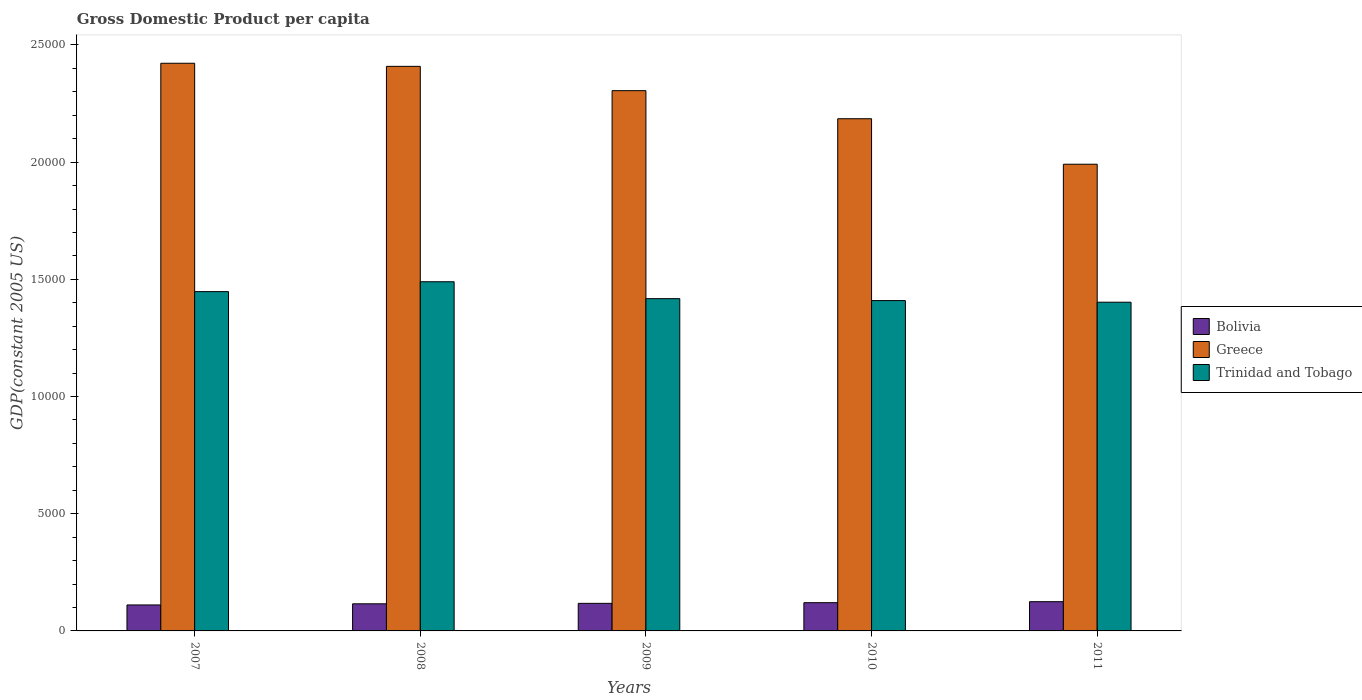How many groups of bars are there?
Give a very brief answer. 5. How many bars are there on the 3rd tick from the left?
Your response must be concise. 3. How many bars are there on the 2nd tick from the right?
Offer a terse response. 3. What is the label of the 4th group of bars from the left?
Your answer should be compact. 2010. What is the GDP per capita in Greece in 2007?
Your response must be concise. 2.42e+04. Across all years, what is the maximum GDP per capita in Trinidad and Tobago?
Make the answer very short. 1.49e+04. Across all years, what is the minimum GDP per capita in Greece?
Provide a succinct answer. 1.99e+04. In which year was the GDP per capita in Trinidad and Tobago maximum?
Offer a very short reply. 2008. In which year was the GDP per capita in Trinidad and Tobago minimum?
Offer a very short reply. 2011. What is the total GDP per capita in Bolivia in the graph?
Your answer should be very brief. 5894.78. What is the difference between the GDP per capita in Bolivia in 2007 and that in 2008?
Your answer should be very brief. -48.73. What is the difference between the GDP per capita in Bolivia in 2007 and the GDP per capita in Greece in 2009?
Ensure brevity in your answer.  -2.19e+04. What is the average GDP per capita in Bolivia per year?
Keep it short and to the point. 1178.96. In the year 2010, what is the difference between the GDP per capita in Greece and GDP per capita in Bolivia?
Your answer should be very brief. 2.06e+04. In how many years, is the GDP per capita in Greece greater than 20000 US$?
Your answer should be compact. 4. What is the ratio of the GDP per capita in Trinidad and Tobago in 2007 to that in 2011?
Offer a terse response. 1.03. Is the GDP per capita in Greece in 2008 less than that in 2011?
Your response must be concise. No. What is the difference between the highest and the second highest GDP per capita in Trinidad and Tobago?
Your response must be concise. 421.24. What is the difference between the highest and the lowest GDP per capita in Bolivia?
Your answer should be compact. 139.55. In how many years, is the GDP per capita in Bolivia greater than the average GDP per capita in Bolivia taken over all years?
Offer a terse response. 2. Is the sum of the GDP per capita in Trinidad and Tobago in 2008 and 2009 greater than the maximum GDP per capita in Greece across all years?
Keep it short and to the point. Yes. What does the 2nd bar from the left in 2011 represents?
Provide a short and direct response. Greece. What does the 1st bar from the right in 2009 represents?
Provide a short and direct response. Trinidad and Tobago. How many bars are there?
Provide a succinct answer. 15. Are all the bars in the graph horizontal?
Your answer should be compact. No. Are the values on the major ticks of Y-axis written in scientific E-notation?
Your answer should be very brief. No. Does the graph contain any zero values?
Your response must be concise. No. Does the graph contain grids?
Offer a very short reply. No. How many legend labels are there?
Offer a very short reply. 3. How are the legend labels stacked?
Your answer should be very brief. Vertical. What is the title of the graph?
Provide a succinct answer. Gross Domestic Product per capita. What is the label or title of the Y-axis?
Your response must be concise. GDP(constant 2005 US). What is the GDP(constant 2005 US) in Bolivia in 2007?
Make the answer very short. 1108.29. What is the GDP(constant 2005 US) in Greece in 2007?
Give a very brief answer. 2.42e+04. What is the GDP(constant 2005 US) in Trinidad and Tobago in 2007?
Ensure brevity in your answer.  1.45e+04. What is the GDP(constant 2005 US) in Bolivia in 2008?
Give a very brief answer. 1157.02. What is the GDP(constant 2005 US) in Greece in 2008?
Your answer should be compact. 2.41e+04. What is the GDP(constant 2005 US) in Trinidad and Tobago in 2008?
Your answer should be very brief. 1.49e+04. What is the GDP(constant 2005 US) of Bolivia in 2009?
Keep it short and to the point. 1176.39. What is the GDP(constant 2005 US) of Greece in 2009?
Your response must be concise. 2.31e+04. What is the GDP(constant 2005 US) of Trinidad and Tobago in 2009?
Offer a very short reply. 1.42e+04. What is the GDP(constant 2005 US) of Bolivia in 2010?
Your response must be concise. 1205.24. What is the GDP(constant 2005 US) of Greece in 2010?
Offer a very short reply. 2.19e+04. What is the GDP(constant 2005 US) in Trinidad and Tobago in 2010?
Offer a very short reply. 1.41e+04. What is the GDP(constant 2005 US) in Bolivia in 2011?
Your response must be concise. 1247.84. What is the GDP(constant 2005 US) in Greece in 2011?
Give a very brief answer. 1.99e+04. What is the GDP(constant 2005 US) in Trinidad and Tobago in 2011?
Make the answer very short. 1.40e+04. Across all years, what is the maximum GDP(constant 2005 US) in Bolivia?
Your response must be concise. 1247.84. Across all years, what is the maximum GDP(constant 2005 US) in Greece?
Your response must be concise. 2.42e+04. Across all years, what is the maximum GDP(constant 2005 US) in Trinidad and Tobago?
Provide a short and direct response. 1.49e+04. Across all years, what is the minimum GDP(constant 2005 US) of Bolivia?
Make the answer very short. 1108.29. Across all years, what is the minimum GDP(constant 2005 US) in Greece?
Give a very brief answer. 1.99e+04. Across all years, what is the minimum GDP(constant 2005 US) in Trinidad and Tobago?
Your answer should be compact. 1.40e+04. What is the total GDP(constant 2005 US) of Bolivia in the graph?
Provide a short and direct response. 5894.78. What is the total GDP(constant 2005 US) of Greece in the graph?
Ensure brevity in your answer.  1.13e+05. What is the total GDP(constant 2005 US) in Trinidad and Tobago in the graph?
Your answer should be very brief. 7.17e+04. What is the difference between the GDP(constant 2005 US) in Bolivia in 2007 and that in 2008?
Ensure brevity in your answer.  -48.73. What is the difference between the GDP(constant 2005 US) of Greece in 2007 and that in 2008?
Your answer should be compact. 131.75. What is the difference between the GDP(constant 2005 US) of Trinidad and Tobago in 2007 and that in 2008?
Offer a terse response. -421.24. What is the difference between the GDP(constant 2005 US) in Bolivia in 2007 and that in 2009?
Your answer should be very brief. -68.1. What is the difference between the GDP(constant 2005 US) of Greece in 2007 and that in 2009?
Your answer should be very brief. 1169.02. What is the difference between the GDP(constant 2005 US) of Trinidad and Tobago in 2007 and that in 2009?
Your answer should be compact. 300.1. What is the difference between the GDP(constant 2005 US) in Bolivia in 2007 and that in 2010?
Offer a very short reply. -96.95. What is the difference between the GDP(constant 2005 US) in Greece in 2007 and that in 2010?
Your response must be concise. 2366.25. What is the difference between the GDP(constant 2005 US) of Trinidad and Tobago in 2007 and that in 2010?
Your answer should be very brief. 382.35. What is the difference between the GDP(constant 2005 US) in Bolivia in 2007 and that in 2011?
Keep it short and to the point. -139.55. What is the difference between the GDP(constant 2005 US) in Greece in 2007 and that in 2011?
Offer a terse response. 4307.98. What is the difference between the GDP(constant 2005 US) in Trinidad and Tobago in 2007 and that in 2011?
Ensure brevity in your answer.  452.1. What is the difference between the GDP(constant 2005 US) of Bolivia in 2008 and that in 2009?
Your response must be concise. -19.37. What is the difference between the GDP(constant 2005 US) of Greece in 2008 and that in 2009?
Offer a terse response. 1037.27. What is the difference between the GDP(constant 2005 US) of Trinidad and Tobago in 2008 and that in 2009?
Offer a very short reply. 721.35. What is the difference between the GDP(constant 2005 US) in Bolivia in 2008 and that in 2010?
Ensure brevity in your answer.  -48.23. What is the difference between the GDP(constant 2005 US) in Greece in 2008 and that in 2010?
Offer a very short reply. 2234.5. What is the difference between the GDP(constant 2005 US) of Trinidad and Tobago in 2008 and that in 2010?
Give a very brief answer. 803.6. What is the difference between the GDP(constant 2005 US) of Bolivia in 2008 and that in 2011?
Your answer should be very brief. -90.82. What is the difference between the GDP(constant 2005 US) of Greece in 2008 and that in 2011?
Your answer should be compact. 4176.24. What is the difference between the GDP(constant 2005 US) in Trinidad and Tobago in 2008 and that in 2011?
Keep it short and to the point. 873.34. What is the difference between the GDP(constant 2005 US) of Bolivia in 2009 and that in 2010?
Your answer should be very brief. -28.85. What is the difference between the GDP(constant 2005 US) of Greece in 2009 and that in 2010?
Provide a succinct answer. 1197.23. What is the difference between the GDP(constant 2005 US) of Trinidad and Tobago in 2009 and that in 2010?
Provide a succinct answer. 82.25. What is the difference between the GDP(constant 2005 US) in Bolivia in 2009 and that in 2011?
Offer a terse response. -71.45. What is the difference between the GDP(constant 2005 US) of Greece in 2009 and that in 2011?
Keep it short and to the point. 3138.97. What is the difference between the GDP(constant 2005 US) of Trinidad and Tobago in 2009 and that in 2011?
Provide a succinct answer. 152. What is the difference between the GDP(constant 2005 US) of Bolivia in 2010 and that in 2011?
Ensure brevity in your answer.  -42.59. What is the difference between the GDP(constant 2005 US) in Greece in 2010 and that in 2011?
Give a very brief answer. 1941.73. What is the difference between the GDP(constant 2005 US) in Trinidad and Tobago in 2010 and that in 2011?
Provide a succinct answer. 69.74. What is the difference between the GDP(constant 2005 US) in Bolivia in 2007 and the GDP(constant 2005 US) in Greece in 2008?
Offer a very short reply. -2.30e+04. What is the difference between the GDP(constant 2005 US) in Bolivia in 2007 and the GDP(constant 2005 US) in Trinidad and Tobago in 2008?
Offer a very short reply. -1.38e+04. What is the difference between the GDP(constant 2005 US) in Greece in 2007 and the GDP(constant 2005 US) in Trinidad and Tobago in 2008?
Provide a succinct answer. 9321.65. What is the difference between the GDP(constant 2005 US) of Bolivia in 2007 and the GDP(constant 2005 US) of Greece in 2009?
Your answer should be very brief. -2.19e+04. What is the difference between the GDP(constant 2005 US) of Bolivia in 2007 and the GDP(constant 2005 US) of Trinidad and Tobago in 2009?
Make the answer very short. -1.31e+04. What is the difference between the GDP(constant 2005 US) of Greece in 2007 and the GDP(constant 2005 US) of Trinidad and Tobago in 2009?
Your response must be concise. 1.00e+04. What is the difference between the GDP(constant 2005 US) in Bolivia in 2007 and the GDP(constant 2005 US) in Greece in 2010?
Your answer should be compact. -2.07e+04. What is the difference between the GDP(constant 2005 US) in Bolivia in 2007 and the GDP(constant 2005 US) in Trinidad and Tobago in 2010?
Give a very brief answer. -1.30e+04. What is the difference between the GDP(constant 2005 US) in Greece in 2007 and the GDP(constant 2005 US) in Trinidad and Tobago in 2010?
Your answer should be very brief. 1.01e+04. What is the difference between the GDP(constant 2005 US) of Bolivia in 2007 and the GDP(constant 2005 US) of Greece in 2011?
Your answer should be very brief. -1.88e+04. What is the difference between the GDP(constant 2005 US) in Bolivia in 2007 and the GDP(constant 2005 US) in Trinidad and Tobago in 2011?
Offer a terse response. -1.29e+04. What is the difference between the GDP(constant 2005 US) of Greece in 2007 and the GDP(constant 2005 US) of Trinidad and Tobago in 2011?
Your answer should be compact. 1.02e+04. What is the difference between the GDP(constant 2005 US) of Bolivia in 2008 and the GDP(constant 2005 US) of Greece in 2009?
Offer a terse response. -2.19e+04. What is the difference between the GDP(constant 2005 US) in Bolivia in 2008 and the GDP(constant 2005 US) in Trinidad and Tobago in 2009?
Give a very brief answer. -1.30e+04. What is the difference between the GDP(constant 2005 US) of Greece in 2008 and the GDP(constant 2005 US) of Trinidad and Tobago in 2009?
Offer a terse response. 9911.25. What is the difference between the GDP(constant 2005 US) of Bolivia in 2008 and the GDP(constant 2005 US) of Greece in 2010?
Keep it short and to the point. -2.07e+04. What is the difference between the GDP(constant 2005 US) in Bolivia in 2008 and the GDP(constant 2005 US) in Trinidad and Tobago in 2010?
Offer a very short reply. -1.29e+04. What is the difference between the GDP(constant 2005 US) of Greece in 2008 and the GDP(constant 2005 US) of Trinidad and Tobago in 2010?
Provide a short and direct response. 9993.5. What is the difference between the GDP(constant 2005 US) in Bolivia in 2008 and the GDP(constant 2005 US) in Greece in 2011?
Your answer should be compact. -1.88e+04. What is the difference between the GDP(constant 2005 US) of Bolivia in 2008 and the GDP(constant 2005 US) of Trinidad and Tobago in 2011?
Your answer should be compact. -1.29e+04. What is the difference between the GDP(constant 2005 US) in Greece in 2008 and the GDP(constant 2005 US) in Trinidad and Tobago in 2011?
Your response must be concise. 1.01e+04. What is the difference between the GDP(constant 2005 US) of Bolivia in 2009 and the GDP(constant 2005 US) of Greece in 2010?
Your response must be concise. -2.07e+04. What is the difference between the GDP(constant 2005 US) in Bolivia in 2009 and the GDP(constant 2005 US) in Trinidad and Tobago in 2010?
Offer a very short reply. -1.29e+04. What is the difference between the GDP(constant 2005 US) of Greece in 2009 and the GDP(constant 2005 US) of Trinidad and Tobago in 2010?
Give a very brief answer. 8956.23. What is the difference between the GDP(constant 2005 US) in Bolivia in 2009 and the GDP(constant 2005 US) in Greece in 2011?
Ensure brevity in your answer.  -1.87e+04. What is the difference between the GDP(constant 2005 US) of Bolivia in 2009 and the GDP(constant 2005 US) of Trinidad and Tobago in 2011?
Your answer should be very brief. -1.28e+04. What is the difference between the GDP(constant 2005 US) of Greece in 2009 and the GDP(constant 2005 US) of Trinidad and Tobago in 2011?
Keep it short and to the point. 9025.97. What is the difference between the GDP(constant 2005 US) of Bolivia in 2010 and the GDP(constant 2005 US) of Greece in 2011?
Provide a short and direct response. -1.87e+04. What is the difference between the GDP(constant 2005 US) in Bolivia in 2010 and the GDP(constant 2005 US) in Trinidad and Tobago in 2011?
Keep it short and to the point. -1.28e+04. What is the difference between the GDP(constant 2005 US) in Greece in 2010 and the GDP(constant 2005 US) in Trinidad and Tobago in 2011?
Provide a succinct answer. 7828.74. What is the average GDP(constant 2005 US) in Bolivia per year?
Ensure brevity in your answer.  1178.96. What is the average GDP(constant 2005 US) of Greece per year?
Provide a short and direct response. 2.26e+04. What is the average GDP(constant 2005 US) of Trinidad and Tobago per year?
Your response must be concise. 1.43e+04. In the year 2007, what is the difference between the GDP(constant 2005 US) in Bolivia and GDP(constant 2005 US) in Greece?
Provide a succinct answer. -2.31e+04. In the year 2007, what is the difference between the GDP(constant 2005 US) of Bolivia and GDP(constant 2005 US) of Trinidad and Tobago?
Keep it short and to the point. -1.34e+04. In the year 2007, what is the difference between the GDP(constant 2005 US) of Greece and GDP(constant 2005 US) of Trinidad and Tobago?
Your answer should be compact. 9742.89. In the year 2008, what is the difference between the GDP(constant 2005 US) in Bolivia and GDP(constant 2005 US) in Greece?
Provide a succinct answer. -2.29e+04. In the year 2008, what is the difference between the GDP(constant 2005 US) of Bolivia and GDP(constant 2005 US) of Trinidad and Tobago?
Your response must be concise. -1.37e+04. In the year 2008, what is the difference between the GDP(constant 2005 US) of Greece and GDP(constant 2005 US) of Trinidad and Tobago?
Ensure brevity in your answer.  9189.9. In the year 2009, what is the difference between the GDP(constant 2005 US) of Bolivia and GDP(constant 2005 US) of Greece?
Give a very brief answer. -2.19e+04. In the year 2009, what is the difference between the GDP(constant 2005 US) in Bolivia and GDP(constant 2005 US) in Trinidad and Tobago?
Your answer should be compact. -1.30e+04. In the year 2009, what is the difference between the GDP(constant 2005 US) of Greece and GDP(constant 2005 US) of Trinidad and Tobago?
Your answer should be very brief. 8873.98. In the year 2010, what is the difference between the GDP(constant 2005 US) of Bolivia and GDP(constant 2005 US) of Greece?
Provide a short and direct response. -2.06e+04. In the year 2010, what is the difference between the GDP(constant 2005 US) in Bolivia and GDP(constant 2005 US) in Trinidad and Tobago?
Offer a terse response. -1.29e+04. In the year 2010, what is the difference between the GDP(constant 2005 US) in Greece and GDP(constant 2005 US) in Trinidad and Tobago?
Your response must be concise. 7758.99. In the year 2011, what is the difference between the GDP(constant 2005 US) of Bolivia and GDP(constant 2005 US) of Greece?
Give a very brief answer. -1.87e+04. In the year 2011, what is the difference between the GDP(constant 2005 US) of Bolivia and GDP(constant 2005 US) of Trinidad and Tobago?
Provide a short and direct response. -1.28e+04. In the year 2011, what is the difference between the GDP(constant 2005 US) in Greece and GDP(constant 2005 US) in Trinidad and Tobago?
Ensure brevity in your answer.  5887.01. What is the ratio of the GDP(constant 2005 US) in Bolivia in 2007 to that in 2008?
Offer a terse response. 0.96. What is the ratio of the GDP(constant 2005 US) in Greece in 2007 to that in 2008?
Your answer should be very brief. 1.01. What is the ratio of the GDP(constant 2005 US) of Trinidad and Tobago in 2007 to that in 2008?
Give a very brief answer. 0.97. What is the ratio of the GDP(constant 2005 US) in Bolivia in 2007 to that in 2009?
Make the answer very short. 0.94. What is the ratio of the GDP(constant 2005 US) of Greece in 2007 to that in 2009?
Your answer should be compact. 1.05. What is the ratio of the GDP(constant 2005 US) in Trinidad and Tobago in 2007 to that in 2009?
Give a very brief answer. 1.02. What is the ratio of the GDP(constant 2005 US) in Bolivia in 2007 to that in 2010?
Make the answer very short. 0.92. What is the ratio of the GDP(constant 2005 US) in Greece in 2007 to that in 2010?
Offer a terse response. 1.11. What is the ratio of the GDP(constant 2005 US) in Trinidad and Tobago in 2007 to that in 2010?
Your answer should be compact. 1.03. What is the ratio of the GDP(constant 2005 US) of Bolivia in 2007 to that in 2011?
Your response must be concise. 0.89. What is the ratio of the GDP(constant 2005 US) in Greece in 2007 to that in 2011?
Give a very brief answer. 1.22. What is the ratio of the GDP(constant 2005 US) in Trinidad and Tobago in 2007 to that in 2011?
Give a very brief answer. 1.03. What is the ratio of the GDP(constant 2005 US) of Bolivia in 2008 to that in 2009?
Your answer should be very brief. 0.98. What is the ratio of the GDP(constant 2005 US) of Greece in 2008 to that in 2009?
Provide a short and direct response. 1.04. What is the ratio of the GDP(constant 2005 US) in Trinidad and Tobago in 2008 to that in 2009?
Make the answer very short. 1.05. What is the ratio of the GDP(constant 2005 US) in Bolivia in 2008 to that in 2010?
Your response must be concise. 0.96. What is the ratio of the GDP(constant 2005 US) of Greece in 2008 to that in 2010?
Offer a terse response. 1.1. What is the ratio of the GDP(constant 2005 US) in Trinidad and Tobago in 2008 to that in 2010?
Offer a very short reply. 1.06. What is the ratio of the GDP(constant 2005 US) in Bolivia in 2008 to that in 2011?
Ensure brevity in your answer.  0.93. What is the ratio of the GDP(constant 2005 US) in Greece in 2008 to that in 2011?
Offer a very short reply. 1.21. What is the ratio of the GDP(constant 2005 US) in Trinidad and Tobago in 2008 to that in 2011?
Ensure brevity in your answer.  1.06. What is the ratio of the GDP(constant 2005 US) of Bolivia in 2009 to that in 2010?
Keep it short and to the point. 0.98. What is the ratio of the GDP(constant 2005 US) in Greece in 2009 to that in 2010?
Make the answer very short. 1.05. What is the ratio of the GDP(constant 2005 US) of Bolivia in 2009 to that in 2011?
Make the answer very short. 0.94. What is the ratio of the GDP(constant 2005 US) of Greece in 2009 to that in 2011?
Keep it short and to the point. 1.16. What is the ratio of the GDP(constant 2005 US) of Trinidad and Tobago in 2009 to that in 2011?
Offer a very short reply. 1.01. What is the ratio of the GDP(constant 2005 US) of Bolivia in 2010 to that in 2011?
Offer a terse response. 0.97. What is the ratio of the GDP(constant 2005 US) in Greece in 2010 to that in 2011?
Give a very brief answer. 1.1. What is the ratio of the GDP(constant 2005 US) of Trinidad and Tobago in 2010 to that in 2011?
Provide a succinct answer. 1. What is the difference between the highest and the second highest GDP(constant 2005 US) in Bolivia?
Provide a succinct answer. 42.59. What is the difference between the highest and the second highest GDP(constant 2005 US) of Greece?
Provide a succinct answer. 131.75. What is the difference between the highest and the second highest GDP(constant 2005 US) in Trinidad and Tobago?
Your answer should be very brief. 421.24. What is the difference between the highest and the lowest GDP(constant 2005 US) of Bolivia?
Ensure brevity in your answer.  139.55. What is the difference between the highest and the lowest GDP(constant 2005 US) in Greece?
Provide a short and direct response. 4307.98. What is the difference between the highest and the lowest GDP(constant 2005 US) of Trinidad and Tobago?
Give a very brief answer. 873.34. 